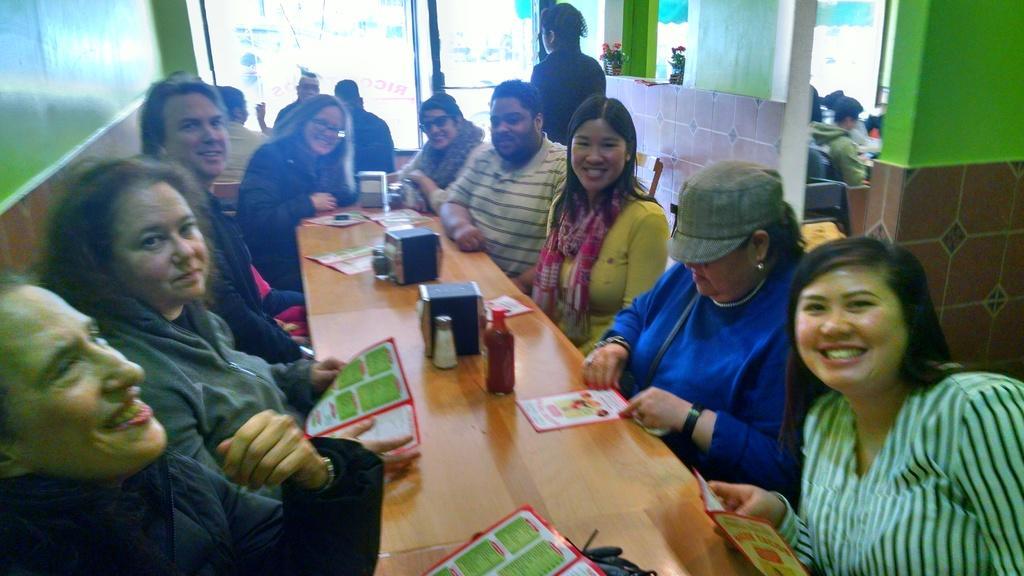Can you describe this image briefly? In this image we can see there are a few people sitting and smiling, in front of them there is a table. On the table there are few objects placed on it, beside them there is another room. In that room there are other people sitting. In the background there is a glass door. 